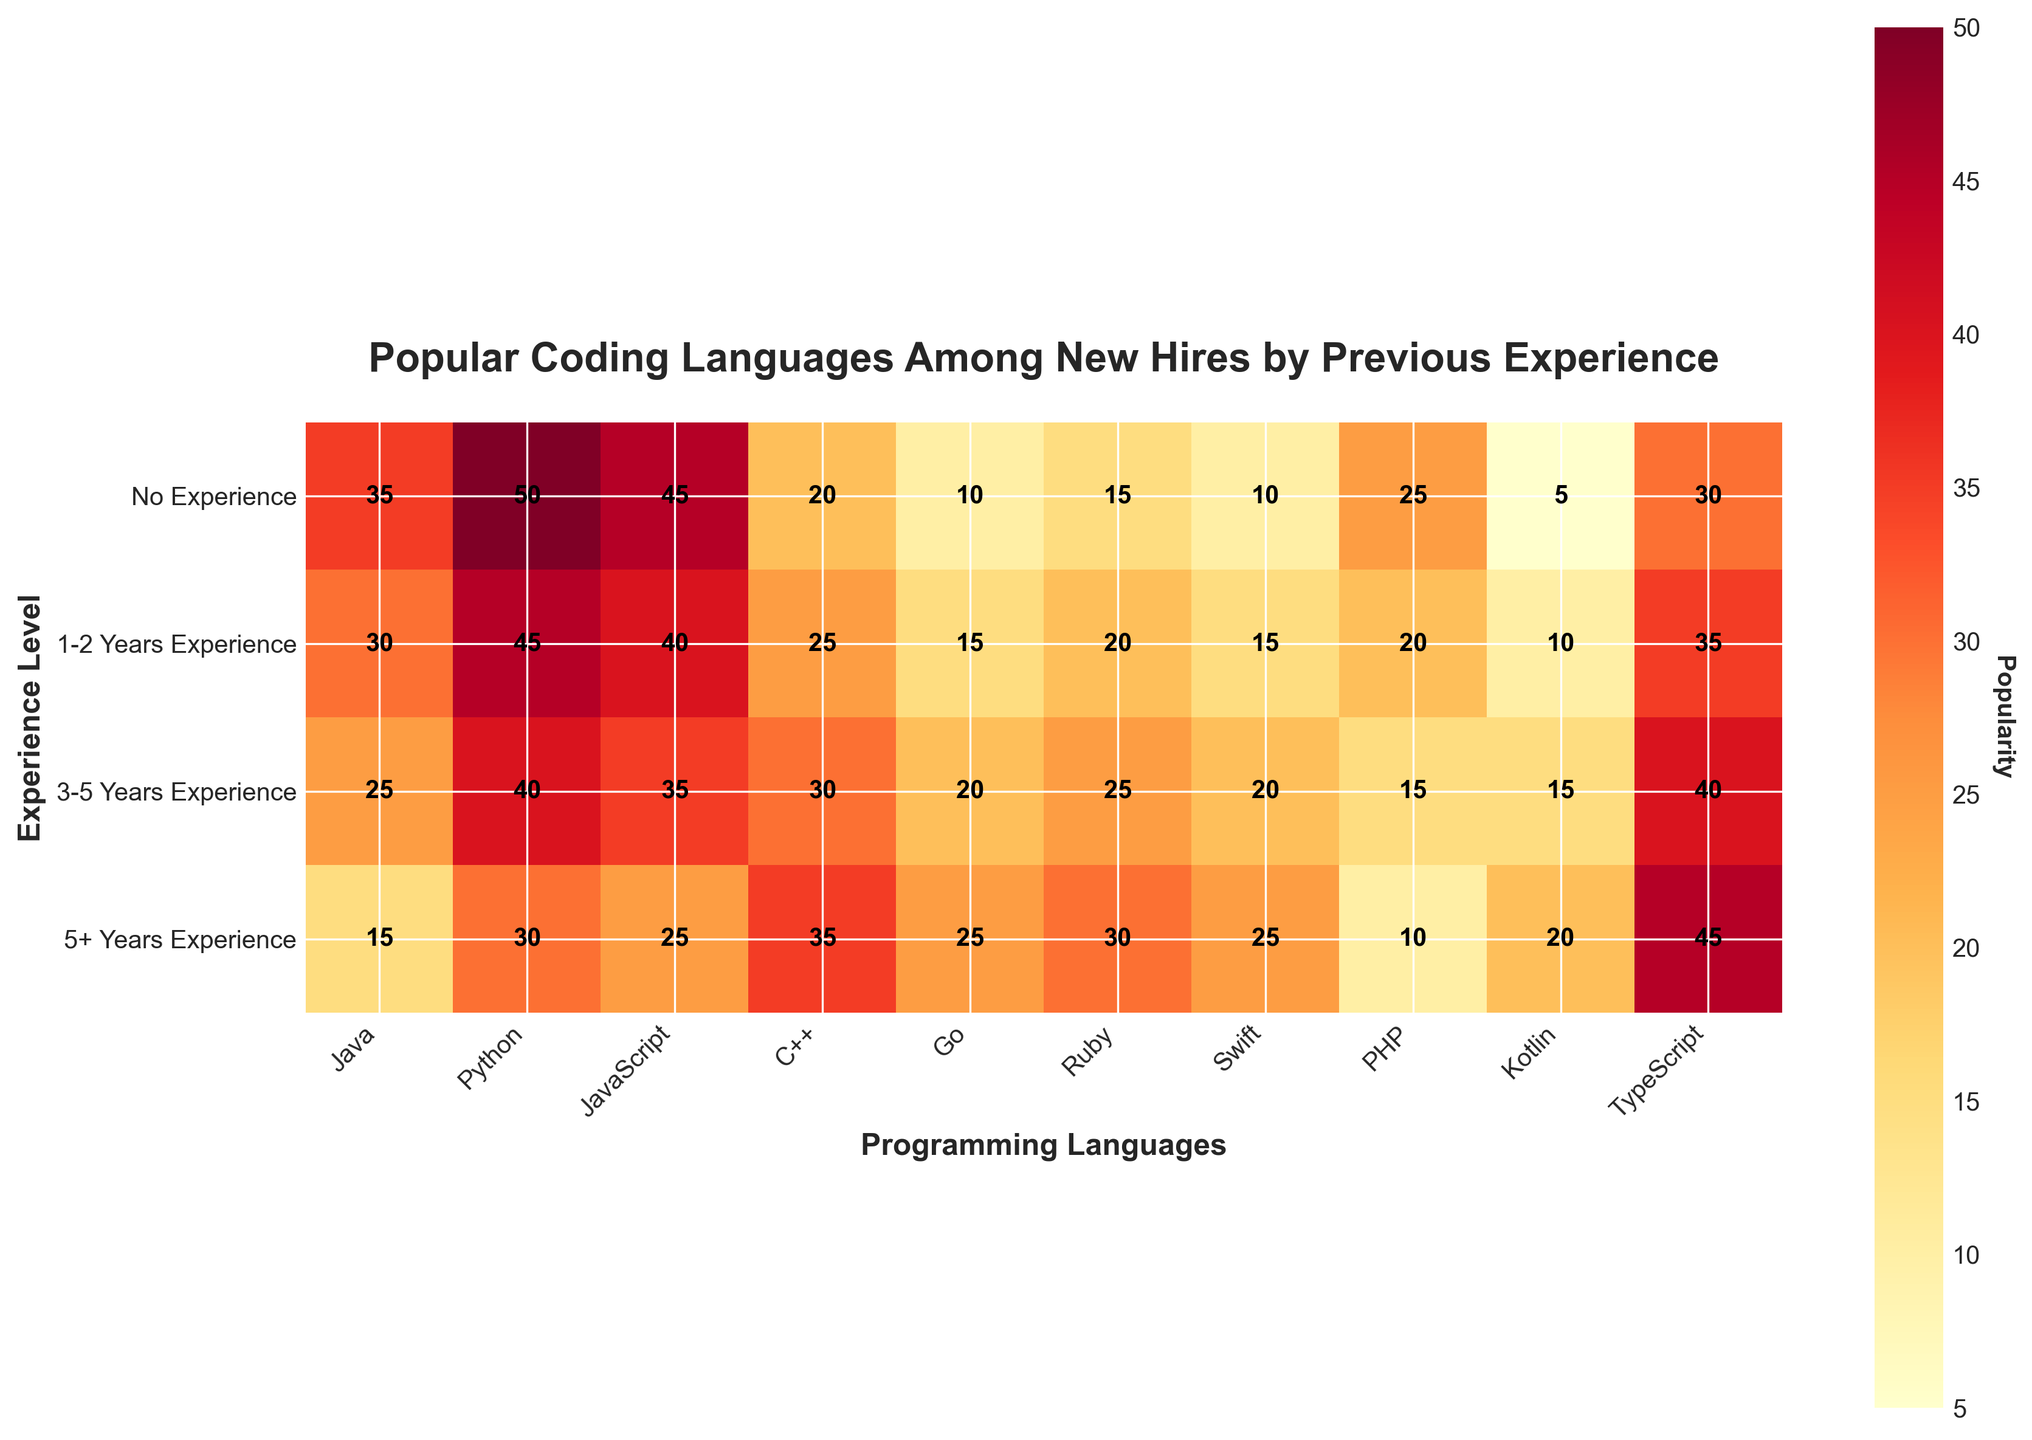what's the title of this heatmap? The title of the heatmap is usually placed at the top of the figure. It provides a summary of the visualized data. In this case, the title is "Popular Coding Languages Among New Hires by Previous Experience."
Answer: Popular Coding Languages Among New Hires by Previous Experience how many categories of experience levels are shown? To determine the number of categories for experience levels, look at the y-axis labels. There are 4 different experience levels: "No Experience," "1-2 Years Experience," "3-5 Years Experience," and "5+ Years Experience."
Answer: 4 which programming language is most popular among hires with no experience? To find the most popular language among hires with no experience, look at the row labeled "No Experience" and find the highest value. Python has a value of 50, which is the highest.
Answer: Python What's the total popularity of TypeScript across all experience levels? To get the total popularity of TypeScript, sum the values of TypeScript across all experience levels: 30 (No Experience) + 35 (1-2 Years Experience) + 40 (3-5 Years Experience) + 45 (5+ Years Experience). The total is 150.
Answer: 150 which programming language shows increasing popularity with increasing experience levels? To identify this, look at the values for each language across different experience levels. TypeScript shows increasing numbers: 30 (No Experience), 35 (1-2 Years Experience), 40 (3-5 Years Experience), and 45 (5+ Years Experience).
Answer: TypeScript what is the average popularity of Java among all experience levels? Calculate the average by summing the popularity values for Java across all experience levels and then dividing by the number of experience levels: (35 + 30 + 25 + 15) / 4. The average is 26.25.
Answer: 26.25 which language is the least popular among hires with 3-5 years of experience? To find the least popular language among hires with 3-5 years of experience, look at the row labeled "3-5 Years Experience" and find the lowest value. PHP has a value of 15, which is the lowest.
Answer: PHP how does the popularity of C++ change with experience levels? To understand the change in popularity of C++ with experience levels, observe the values for C++ across all experience categories: 20 (No Experience), 25 (1-2 Years Experience), 30 (3-5 Years Experience), 35 (5+ Years Experience). The popularity increases as the experience level increases.
Answer: Increases which experience level has the lowest popularity for Kotlin? To find out which experience level has the lowest popularity for Kotlin, look at the values for Kotlin across all experience levels. "No Experience" has a value of 5, which is the lowest.
Answer: No Experience 